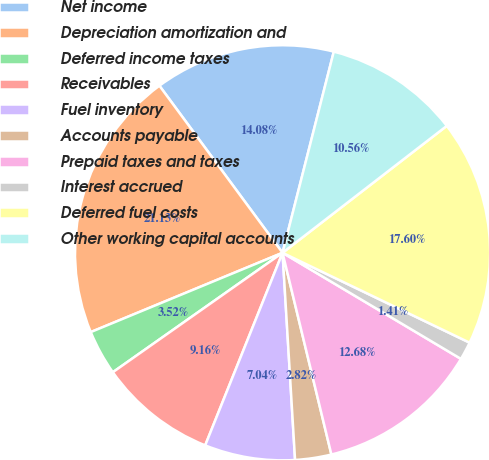Convert chart to OTSL. <chart><loc_0><loc_0><loc_500><loc_500><pie_chart><fcel>Net income<fcel>Depreciation amortization and<fcel>Deferred income taxes<fcel>Receivables<fcel>Fuel inventory<fcel>Accounts payable<fcel>Prepaid taxes and taxes<fcel>Interest accrued<fcel>Deferred fuel costs<fcel>Other working capital accounts<nl><fcel>14.08%<fcel>21.13%<fcel>3.52%<fcel>9.16%<fcel>7.04%<fcel>2.82%<fcel>12.68%<fcel>1.41%<fcel>17.6%<fcel>10.56%<nl></chart> 